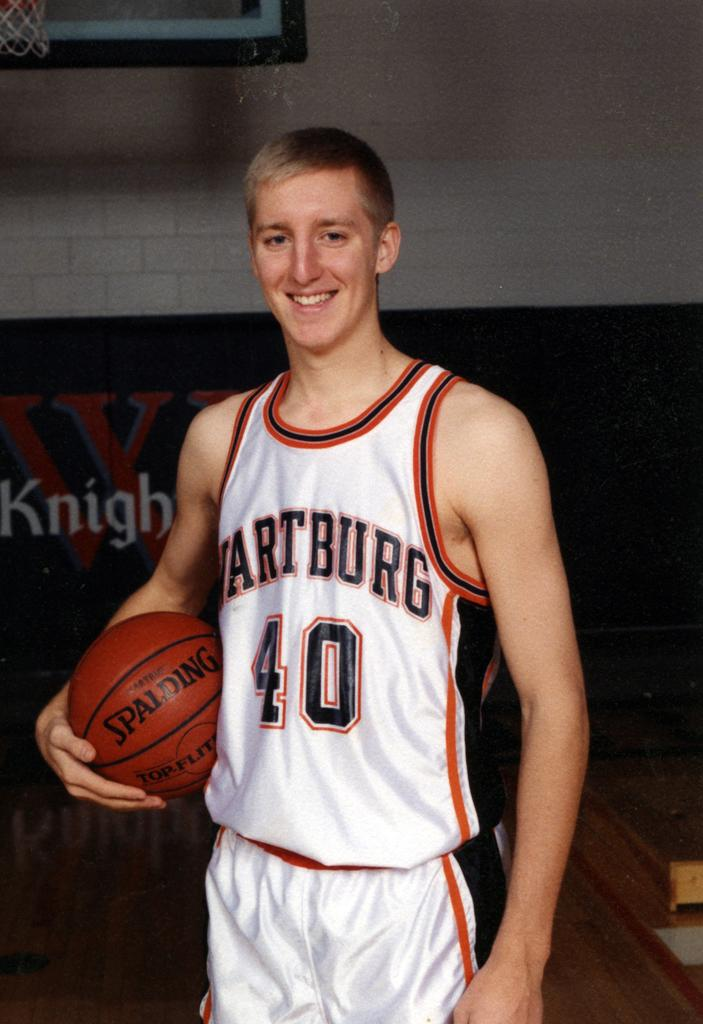<image>
Summarize the visual content of the image. Basketball player wearing number 40 posing for a photo. 